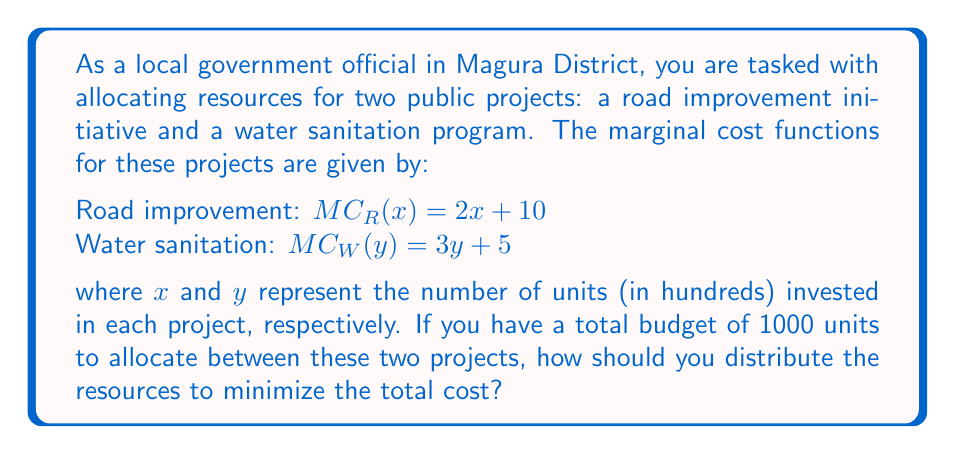Teach me how to tackle this problem. To solve this problem, we'll use marginal cost analysis and the principle that optimal allocation occurs when the marginal costs of both projects are equal. Let's follow these steps:

1) First, we need to set up an equation representing the budget constraint:
   $100x + 100y = 1000$ (since $x$ and $y$ are in hundreds)
   Simplifying: $x + y = 10$

2) For optimal allocation, the marginal costs should be equal:
   $MC_R(x) = MC_W(y)$
   $2x + 10 = 3y + 5$

3) Solve this equation for $x$:
   $2x = 3y - 5$
   $x = \frac{3y - 5}{2}$

4) Substitute this into the budget constraint equation:
   $\frac{3y - 5}{2} + y = 10$
   $3y - 5 + 2y = 20$
   $5y - 5 = 20$
   $5y = 25$
   $y = 5$

5) Now we can find $x$:
   $x + 5 = 10$
   $x = 5$

6) Verify the solution:
   $MC_R(5) = 2(5) + 10 = 20$
   $MC_W(5) = 3(5) + 5 = 20$

   The marginal costs are equal, confirming optimal allocation.

7) Convert back to actual units:
   Road improvement: $5 * 100 = 500$ units
   Water sanitation: $5 * 100 = 500$ units
Answer: Allocate 500 units to road improvement and 500 units to water sanitation. 